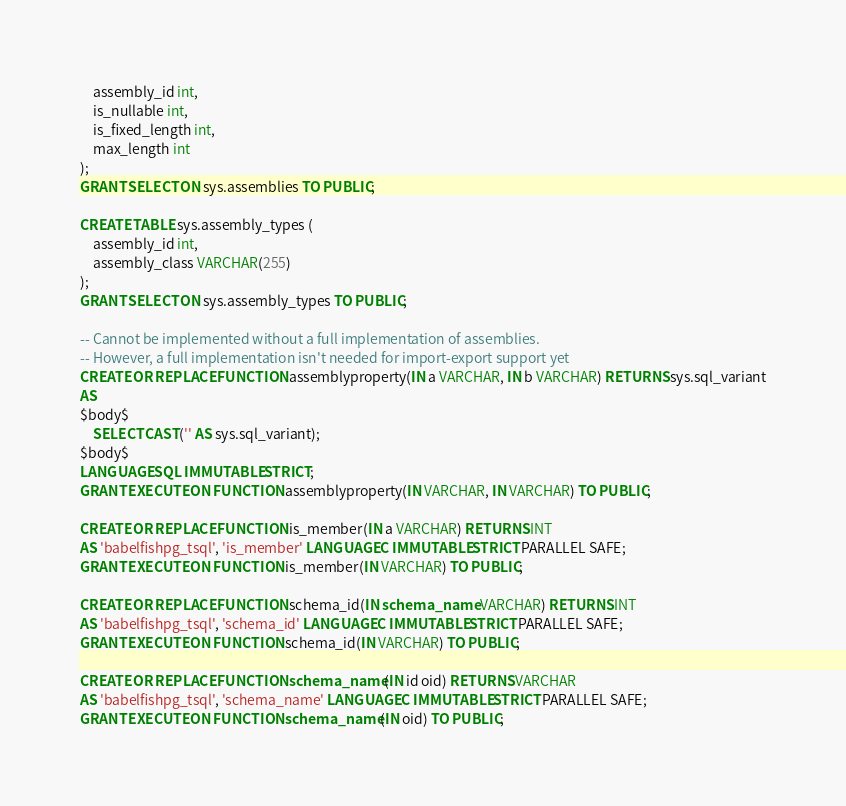<code> <loc_0><loc_0><loc_500><loc_500><_SQL_>	assembly_id int,
	is_nullable int,
	is_fixed_length int,
	max_length int
);
GRANT SELECT ON sys.assemblies TO PUBLIC;

CREATE TABLE sys.assembly_types (
	assembly_id int,
	assembly_class VARCHAR(255)
);
GRANT SELECT ON sys.assembly_types TO PUBLIC;

-- Cannot be implemented without a full implementation of assemblies.
-- However, a full implementation isn't needed for import-export support yet
CREATE OR REPLACE FUNCTION assemblyproperty(IN a VARCHAR, IN b VARCHAR) RETURNS sys.sql_variant
AS
$body$
	SELECT CAST('' AS sys.sql_variant);
$body$
LANGUAGE SQL IMMUTABLE STRICT;
GRANT EXECUTE ON FUNCTION assemblyproperty(IN VARCHAR, IN VARCHAR) TO PUBLIC;

CREATE OR REPLACE FUNCTION is_member(IN a VARCHAR) RETURNS INT
AS 'babelfishpg_tsql', 'is_member' LANGUAGE C IMMUTABLE STRICT PARALLEL SAFE;
GRANT EXECUTE ON FUNCTION is_member(IN VARCHAR) TO PUBLIC;

CREATE OR REPLACE FUNCTION schema_id(IN schema_name VARCHAR) RETURNS INT
AS 'babelfishpg_tsql', 'schema_id' LANGUAGE C IMMUTABLE STRICT PARALLEL SAFE;
GRANT EXECUTE ON FUNCTION schema_id(IN VARCHAR) TO PUBLIC;

CREATE OR REPLACE FUNCTION schema_name(IN id oid) RETURNS VARCHAR
AS 'babelfishpg_tsql', 'schema_name' LANGUAGE C IMMUTABLE STRICT PARALLEL SAFE;
GRANT EXECUTE ON FUNCTION schema_name(IN oid) TO PUBLIC;
</code> 